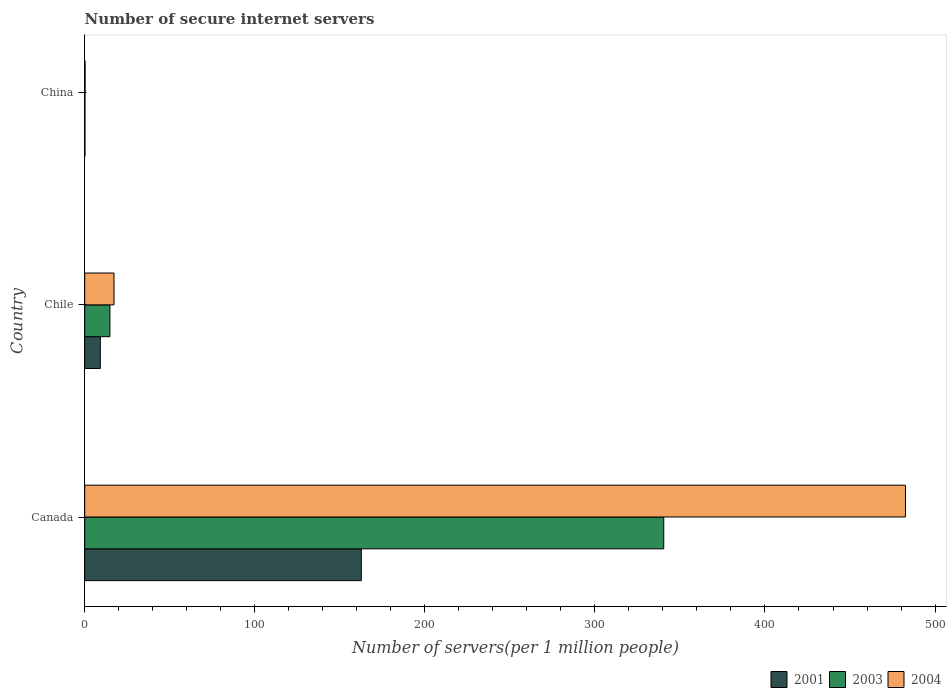Are the number of bars on each tick of the Y-axis equal?
Provide a short and direct response. Yes. How many bars are there on the 3rd tick from the top?
Your response must be concise. 3. How many bars are there on the 3rd tick from the bottom?
Your response must be concise. 3. What is the number of secure internet servers in 2001 in China?
Provide a short and direct response. 0.14. Across all countries, what is the maximum number of secure internet servers in 2001?
Your response must be concise. 162.63. Across all countries, what is the minimum number of secure internet servers in 2003?
Make the answer very short. 0.14. In which country was the number of secure internet servers in 2004 minimum?
Ensure brevity in your answer.  China. What is the total number of secure internet servers in 2003 in the graph?
Provide a short and direct response. 355.43. What is the difference between the number of secure internet servers in 2003 in Canada and that in China?
Keep it short and to the point. 340.34. What is the difference between the number of secure internet servers in 2004 in Canada and the number of secure internet servers in 2001 in China?
Offer a terse response. 482.46. What is the average number of secure internet servers in 2004 per country?
Your response must be concise. 166.68. What is the difference between the number of secure internet servers in 2003 and number of secure internet servers in 2004 in Chile?
Give a very brief answer. -2.41. What is the ratio of the number of secure internet servers in 2004 in Canada to that in China?
Ensure brevity in your answer.  2134.79. Is the number of secure internet servers in 2001 in Chile less than that in China?
Offer a very short reply. No. What is the difference between the highest and the second highest number of secure internet servers in 2003?
Keep it short and to the point. 325.67. What is the difference between the highest and the lowest number of secure internet servers in 2004?
Your answer should be compact. 482.38. In how many countries, is the number of secure internet servers in 2004 greater than the average number of secure internet servers in 2004 taken over all countries?
Provide a short and direct response. 1. What does the 1st bar from the top in China represents?
Keep it short and to the point. 2004. What does the 2nd bar from the bottom in China represents?
Offer a terse response. 2003. Is it the case that in every country, the sum of the number of secure internet servers in 2001 and number of secure internet servers in 2004 is greater than the number of secure internet servers in 2003?
Ensure brevity in your answer.  Yes. How many countries are there in the graph?
Ensure brevity in your answer.  3. What is the difference between two consecutive major ticks on the X-axis?
Give a very brief answer. 100. Are the values on the major ticks of X-axis written in scientific E-notation?
Ensure brevity in your answer.  No. Does the graph contain any zero values?
Give a very brief answer. No. How many legend labels are there?
Your answer should be compact. 3. How are the legend labels stacked?
Offer a very short reply. Horizontal. What is the title of the graph?
Make the answer very short. Number of secure internet servers. What is the label or title of the X-axis?
Your response must be concise. Number of servers(per 1 million people). What is the Number of servers(per 1 million people) of 2001 in Canada?
Make the answer very short. 162.63. What is the Number of servers(per 1 million people) of 2003 in Canada?
Provide a short and direct response. 340.48. What is the Number of servers(per 1 million people) in 2004 in Canada?
Provide a short and direct response. 482.61. What is the Number of servers(per 1 million people) of 2001 in Chile?
Ensure brevity in your answer.  9.18. What is the Number of servers(per 1 million people) of 2003 in Chile?
Make the answer very short. 14.81. What is the Number of servers(per 1 million people) of 2004 in Chile?
Offer a terse response. 17.22. What is the Number of servers(per 1 million people) of 2001 in China?
Ensure brevity in your answer.  0.14. What is the Number of servers(per 1 million people) in 2003 in China?
Give a very brief answer. 0.14. What is the Number of servers(per 1 million people) of 2004 in China?
Give a very brief answer. 0.23. Across all countries, what is the maximum Number of servers(per 1 million people) in 2001?
Your response must be concise. 162.63. Across all countries, what is the maximum Number of servers(per 1 million people) in 2003?
Make the answer very short. 340.48. Across all countries, what is the maximum Number of servers(per 1 million people) of 2004?
Offer a terse response. 482.61. Across all countries, what is the minimum Number of servers(per 1 million people) of 2001?
Give a very brief answer. 0.14. Across all countries, what is the minimum Number of servers(per 1 million people) in 2003?
Your response must be concise. 0.14. Across all countries, what is the minimum Number of servers(per 1 million people) of 2004?
Your response must be concise. 0.23. What is the total Number of servers(per 1 million people) in 2001 in the graph?
Give a very brief answer. 171.96. What is the total Number of servers(per 1 million people) of 2003 in the graph?
Make the answer very short. 355.43. What is the total Number of servers(per 1 million people) of 2004 in the graph?
Your response must be concise. 500.05. What is the difference between the Number of servers(per 1 million people) in 2001 in Canada and that in Chile?
Provide a short and direct response. 153.45. What is the difference between the Number of servers(per 1 million people) of 2003 in Canada and that in Chile?
Your response must be concise. 325.67. What is the difference between the Number of servers(per 1 million people) of 2004 in Canada and that in Chile?
Give a very brief answer. 465.39. What is the difference between the Number of servers(per 1 million people) of 2001 in Canada and that in China?
Your response must be concise. 162.49. What is the difference between the Number of servers(per 1 million people) in 2003 in Canada and that in China?
Ensure brevity in your answer.  340.34. What is the difference between the Number of servers(per 1 million people) of 2004 in Canada and that in China?
Provide a short and direct response. 482.38. What is the difference between the Number of servers(per 1 million people) in 2001 in Chile and that in China?
Your answer should be very brief. 9.04. What is the difference between the Number of servers(per 1 million people) in 2003 in Chile and that in China?
Make the answer very short. 14.67. What is the difference between the Number of servers(per 1 million people) in 2004 in Chile and that in China?
Offer a terse response. 16.99. What is the difference between the Number of servers(per 1 million people) of 2001 in Canada and the Number of servers(per 1 million people) of 2003 in Chile?
Your answer should be very brief. 147.82. What is the difference between the Number of servers(per 1 million people) of 2001 in Canada and the Number of servers(per 1 million people) of 2004 in Chile?
Your answer should be compact. 145.42. What is the difference between the Number of servers(per 1 million people) of 2003 in Canada and the Number of servers(per 1 million people) of 2004 in Chile?
Your answer should be compact. 323.26. What is the difference between the Number of servers(per 1 million people) of 2001 in Canada and the Number of servers(per 1 million people) of 2003 in China?
Give a very brief answer. 162.49. What is the difference between the Number of servers(per 1 million people) of 2001 in Canada and the Number of servers(per 1 million people) of 2004 in China?
Give a very brief answer. 162.41. What is the difference between the Number of servers(per 1 million people) of 2003 in Canada and the Number of servers(per 1 million people) of 2004 in China?
Give a very brief answer. 340.25. What is the difference between the Number of servers(per 1 million people) of 2001 in Chile and the Number of servers(per 1 million people) of 2003 in China?
Provide a succinct answer. 9.04. What is the difference between the Number of servers(per 1 million people) in 2001 in Chile and the Number of servers(per 1 million people) in 2004 in China?
Provide a succinct answer. 8.95. What is the difference between the Number of servers(per 1 million people) in 2003 in Chile and the Number of servers(per 1 million people) in 2004 in China?
Keep it short and to the point. 14.59. What is the average Number of servers(per 1 million people) of 2001 per country?
Keep it short and to the point. 57.32. What is the average Number of servers(per 1 million people) of 2003 per country?
Your answer should be compact. 118.48. What is the average Number of servers(per 1 million people) in 2004 per country?
Provide a succinct answer. 166.68. What is the difference between the Number of servers(per 1 million people) in 2001 and Number of servers(per 1 million people) in 2003 in Canada?
Offer a very short reply. -177.84. What is the difference between the Number of servers(per 1 million people) of 2001 and Number of servers(per 1 million people) of 2004 in Canada?
Give a very brief answer. -319.97. What is the difference between the Number of servers(per 1 million people) in 2003 and Number of servers(per 1 million people) in 2004 in Canada?
Give a very brief answer. -142.13. What is the difference between the Number of servers(per 1 million people) in 2001 and Number of servers(per 1 million people) in 2003 in Chile?
Provide a succinct answer. -5.63. What is the difference between the Number of servers(per 1 million people) in 2001 and Number of servers(per 1 million people) in 2004 in Chile?
Ensure brevity in your answer.  -8.04. What is the difference between the Number of servers(per 1 million people) in 2003 and Number of servers(per 1 million people) in 2004 in Chile?
Give a very brief answer. -2.41. What is the difference between the Number of servers(per 1 million people) of 2001 and Number of servers(per 1 million people) of 2003 in China?
Your answer should be very brief. 0. What is the difference between the Number of servers(per 1 million people) in 2001 and Number of servers(per 1 million people) in 2004 in China?
Ensure brevity in your answer.  -0.08. What is the difference between the Number of servers(per 1 million people) in 2003 and Number of servers(per 1 million people) in 2004 in China?
Ensure brevity in your answer.  -0.08. What is the ratio of the Number of servers(per 1 million people) in 2001 in Canada to that in Chile?
Your response must be concise. 17.71. What is the ratio of the Number of servers(per 1 million people) in 2003 in Canada to that in Chile?
Provide a succinct answer. 22.98. What is the ratio of the Number of servers(per 1 million people) in 2004 in Canada to that in Chile?
Your answer should be compact. 28.03. What is the ratio of the Number of servers(per 1 million people) of 2001 in Canada to that in China?
Offer a terse response. 1124.17. What is the ratio of the Number of servers(per 1 million people) of 2003 in Canada to that in China?
Offer a very short reply. 2410.29. What is the ratio of the Number of servers(per 1 million people) of 2004 in Canada to that in China?
Offer a terse response. 2134.79. What is the ratio of the Number of servers(per 1 million people) of 2001 in Chile to that in China?
Offer a very short reply. 63.46. What is the ratio of the Number of servers(per 1 million people) in 2003 in Chile to that in China?
Make the answer very short. 104.86. What is the ratio of the Number of servers(per 1 million people) of 2004 in Chile to that in China?
Ensure brevity in your answer.  76.17. What is the difference between the highest and the second highest Number of servers(per 1 million people) of 2001?
Make the answer very short. 153.45. What is the difference between the highest and the second highest Number of servers(per 1 million people) of 2003?
Provide a short and direct response. 325.67. What is the difference between the highest and the second highest Number of servers(per 1 million people) in 2004?
Provide a short and direct response. 465.39. What is the difference between the highest and the lowest Number of servers(per 1 million people) of 2001?
Your answer should be compact. 162.49. What is the difference between the highest and the lowest Number of servers(per 1 million people) of 2003?
Make the answer very short. 340.34. What is the difference between the highest and the lowest Number of servers(per 1 million people) in 2004?
Ensure brevity in your answer.  482.38. 